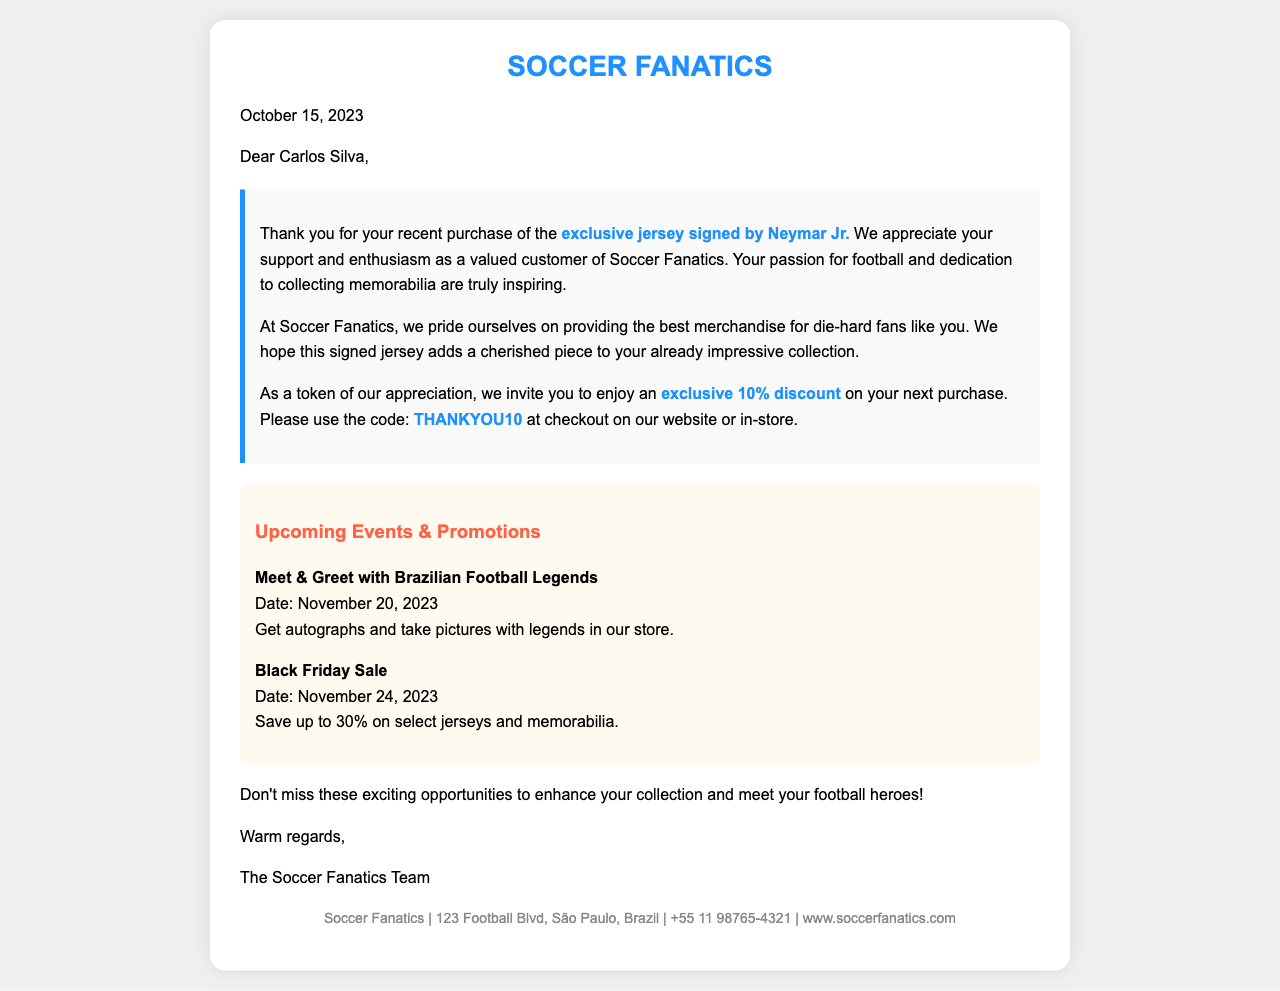What is the recipient's name? The name of the recipient mentioned in the letter is Carlos Silva.
Answer: Carlos Silva What item did Carlos Silva purchase? The letter mentions that Carlos Silva purchased an exclusive jersey signed by Neymar Jr.
Answer: exclusive jersey signed by Neymar Jr What discount code is provided for the next purchase? The letter includes a discount code for the next purchase: THANKYOU10.
Answer: THANKYOU10 What is the date of the upcoming Meet & Greet event? The letter specifies that the Meet & Greet event is on November 20, 2023.
Answer: November 20, 2023 What is the percentage discount during the Black Friday Sale? The document states that customers can save up to 30% during the Black Friday Sale.
Answer: up to 30% What is the shop's name? The letter is from Soccer Fanatics.
Answer: Soccer Fanatics Why is the jersey purchase significant? The purchase is significant as it adds a cherished piece to Carlos Silva's impressive collection.
Answer: cherished piece to your collection What is the location of Soccer Fanatics? The letter mentions the address of Soccer Fanatics as 123 Football Blvd, São Paulo, Brazil.
Answer: 123 Football Blvd, São Paulo, Brazil 